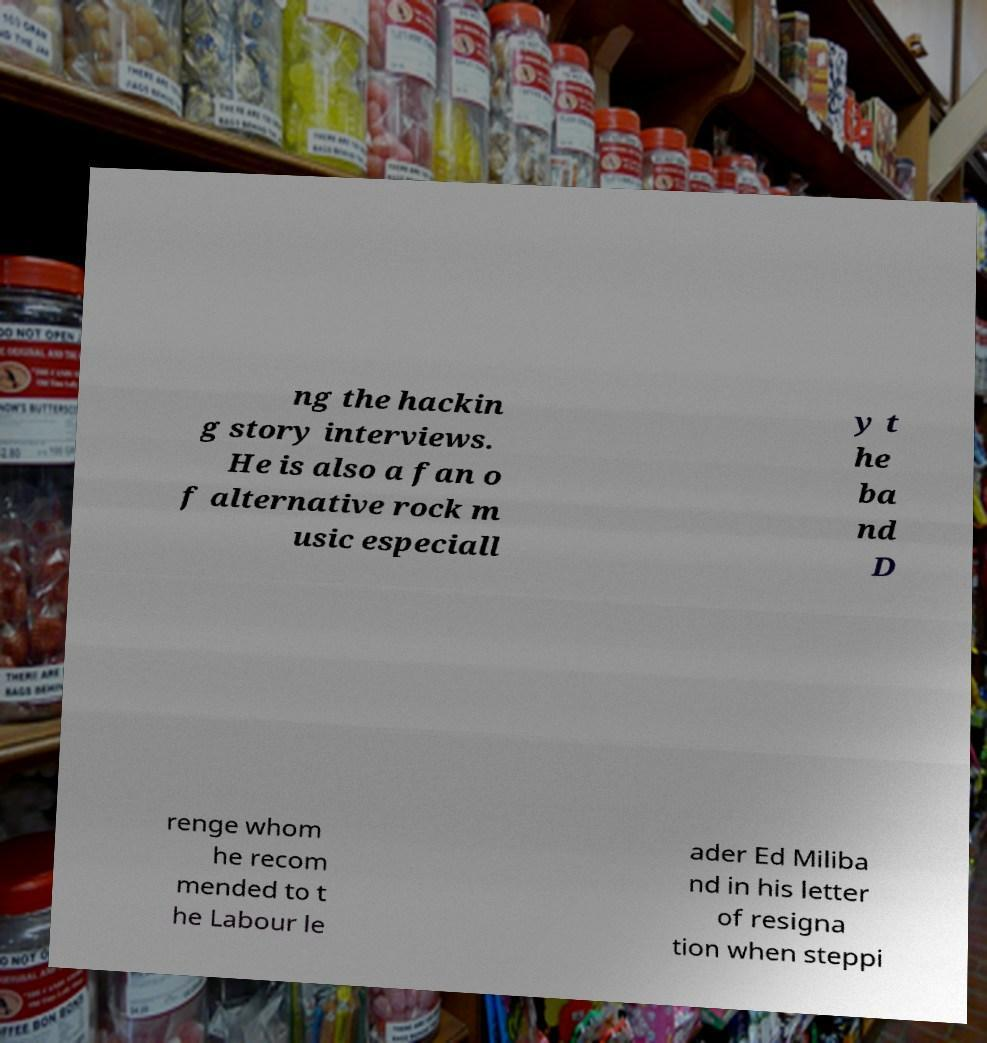Can you read and provide the text displayed in the image?This photo seems to have some interesting text. Can you extract and type it out for me? ng the hackin g story interviews. He is also a fan o f alternative rock m usic especiall y t he ba nd D renge whom he recom mended to t he Labour le ader Ed Miliba nd in his letter of resigna tion when steppi 